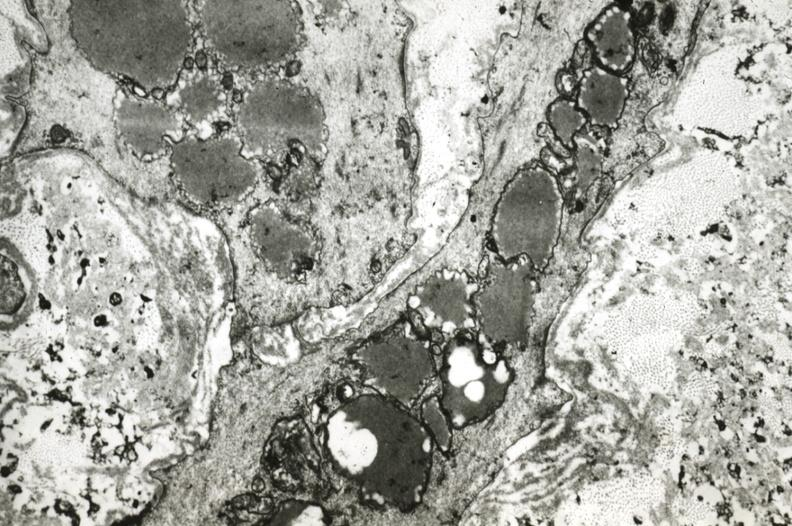does this image show intimal smooth muscle cells with lipid in cytoplasm and precipitated lipid in interstitial space?
Answer the question using a single word or phrase. Yes 